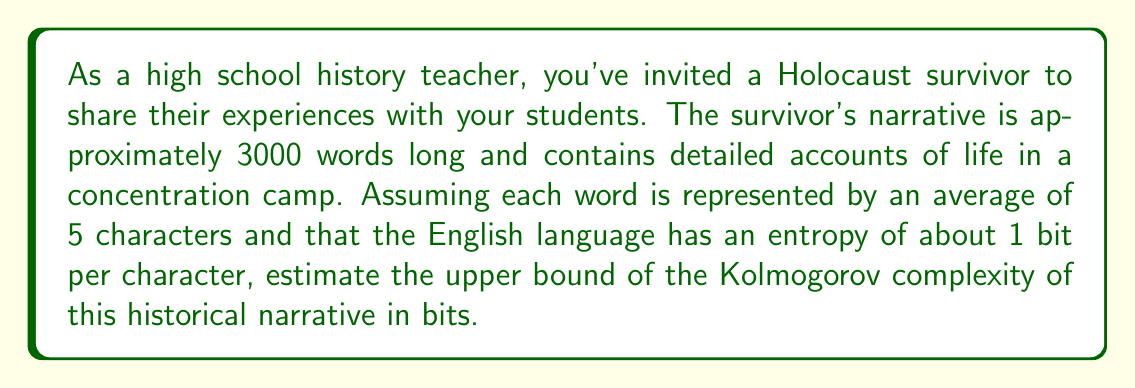Teach me how to tackle this problem. To estimate the upper bound of the Kolmogorov complexity of the historical narrative, we'll follow these steps:

1) First, let's calculate the total number of characters in the narrative:
   $$ \text{Total characters} = 3000 \text{ words} \times 5 \text{ characters/word} = 15000 \text{ characters} $$

2) The Kolmogorov complexity is upper-bounded by the information content of the message. In information theory, the information content is calculated as the product of the number of symbols (characters in this case) and the entropy per symbol.

3) We're given that the English language has an entropy of about 1 bit per character. This means each character carries approximately 1 bit of information.

4) Therefore, we can estimate the upper bound of the Kolmogorov complexity as:
   $$ K(x) \leq 15000 \text{ characters} \times 1 \text{ bit/character} = 15000 \text{ bits} $$

5) This estimate is an upper bound because the Kolmogorov complexity represents the length of the shortest program that can produce the narrative. In reality, there might be more efficient ways to encode the information, especially given the repetitive nature of language and the potential for compression in a coherent narrative.

It's important to note that this is a simplified estimate. The actual Kolmogorov complexity could be lower due to patterns, repetitions, and structure in the narrative that could be more efficiently encoded.
Answer: The upper bound of the Kolmogorov complexity of the historical narrative is estimated to be 15000 bits. 